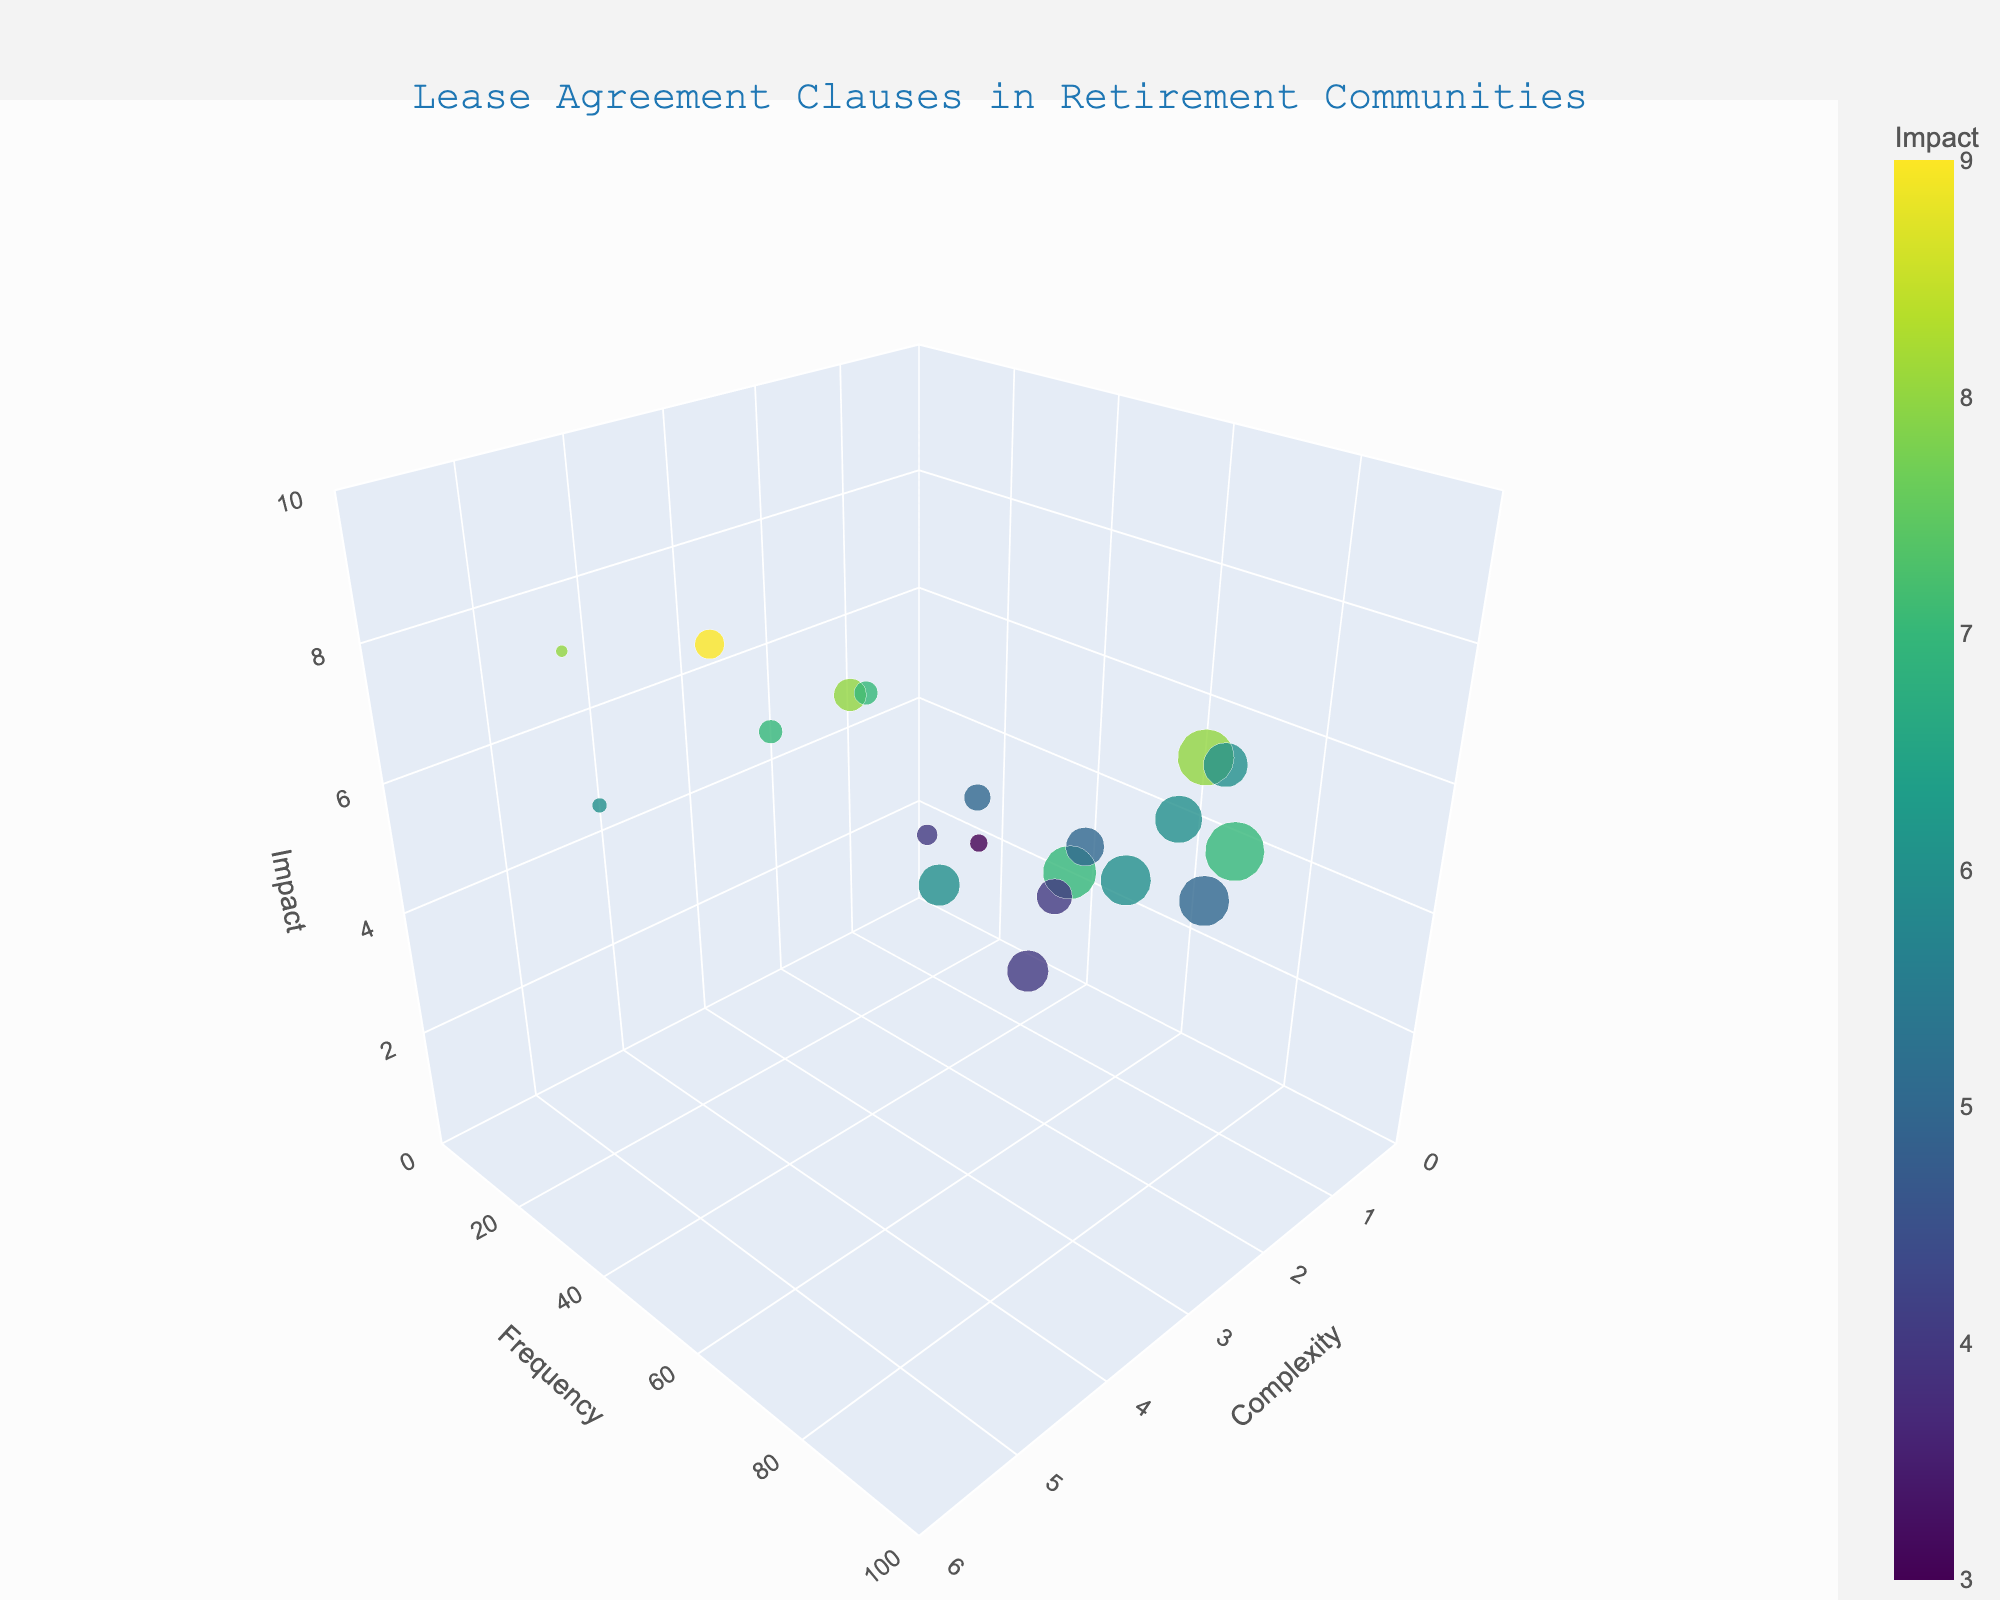Which clause has the highest frequency? To determine this, locate the bubble that is furthest along the 'Frequency' axis. The data point with the highest y-value represents the highest frequency.
Answer: Security Deposit What is the complexity level of the Lease Termination clause? Locate the bubble labeled 'Lease Termination' and note its position along the 'Complexity' axis. The x-value here represents the complexity level.
Answer: 5 How many data points have an impact greater than 7? Look at the 'Impact' axis and count the number of bubbles that are positioned above the z-value of 7.
Answer: 4 Which two clauses have the same complexity but differ in frequency? Find bubbles on the same x-axis level but differing y-axis levels.
Answer: Pet Policy and Noise Restrictions What is the average impact value of utility responsibilities and health emergency procedures? Note the impact values for Utility Responsibilities (6) and Health Emergency Procedures (8). Add them and divide by 2: (6+8)/2.
Answer: 7 Which clause has the highest impact and what is its complexity? Locate the bubble with the highest position on the 'Impact' axis and note its label and x-value for complexity.
Answer: Lease Termination, 5 Is the Maintenance Responsibilities clause more frequent or less frequent than Health Emergency Procedures? Compare the frequency y-values of 'Maintenance Responsibilities' and 'Health Emergency Procedures'.
Answer: More frequent What is the color scheme used in the bubble chart, and what does it represent? Look at the colors of the bubbles and refer to the color legend or scale. The color corresponds to the impact values.
Answer: Viridis, Impact Which clauses have a frequency lower than 50 but a complexity of 2? Identify bubbles at x=2 and y<50. Note the clause names associated.
Answer: Meal Plan Options, Housekeeping Services Are there any clauses with a complexity level of 4 and a different impact of 7? Find bubbles at x-value of 4 and check their z-values. Confirm if they are different but have an impact of 7.
Answer: Yes, Maintenance Responsibilities and Renovation Restrictions 